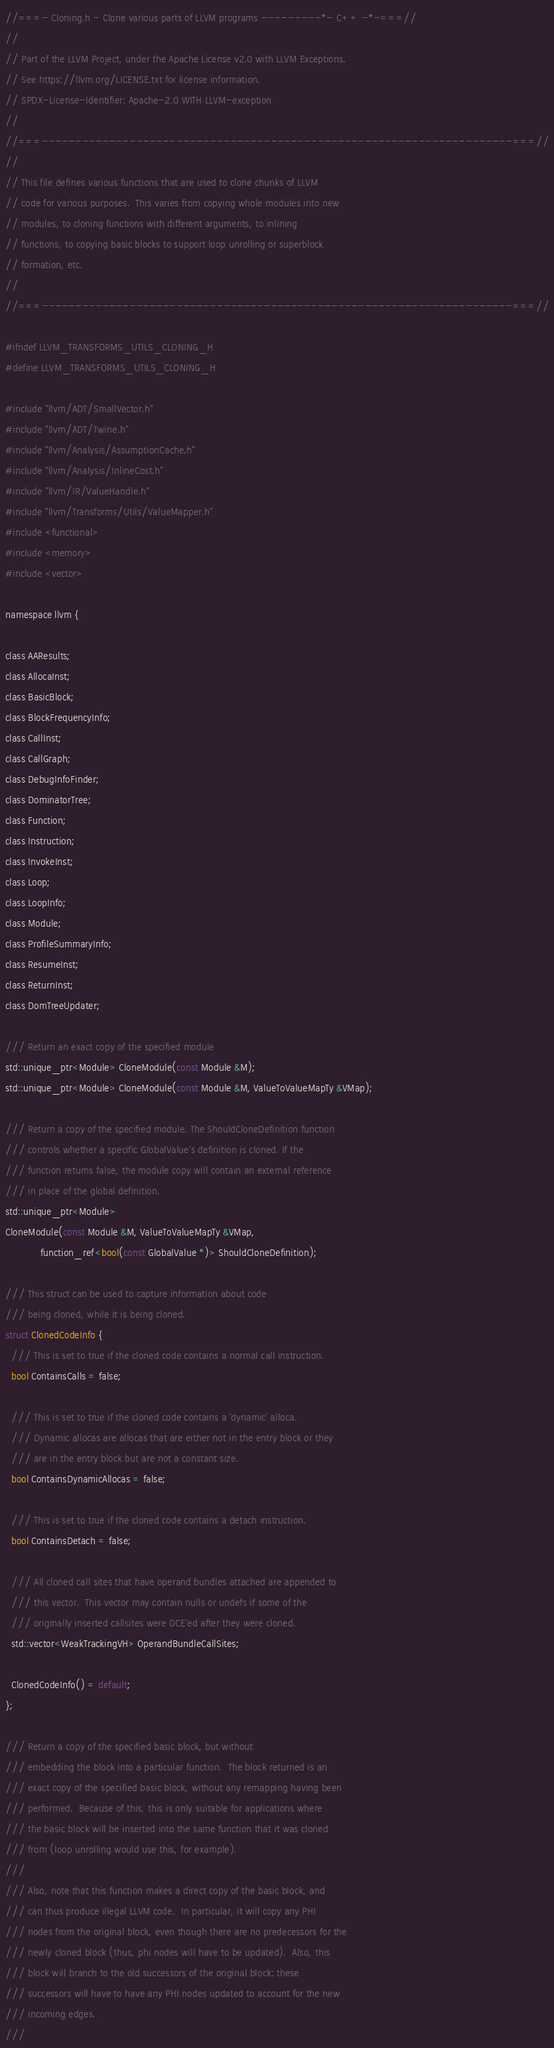Convert code to text. <code><loc_0><loc_0><loc_500><loc_500><_C_>//===- Cloning.h - Clone various parts of LLVM programs ---------*- C++ -*-===//
//
// Part of the LLVM Project, under the Apache License v2.0 with LLVM Exceptions.
// See https://llvm.org/LICENSE.txt for license information.
// SPDX-License-Identifier: Apache-2.0 WITH LLVM-exception
//
//===----------------------------------------------------------------------===//
//
// This file defines various functions that are used to clone chunks of LLVM
// code for various purposes.  This varies from copying whole modules into new
// modules, to cloning functions with different arguments, to inlining
// functions, to copying basic blocks to support loop unrolling or superblock
// formation, etc.
//
//===----------------------------------------------------------------------===//

#ifndef LLVM_TRANSFORMS_UTILS_CLONING_H
#define LLVM_TRANSFORMS_UTILS_CLONING_H

#include "llvm/ADT/SmallVector.h"
#include "llvm/ADT/Twine.h"
#include "llvm/Analysis/AssumptionCache.h"
#include "llvm/Analysis/InlineCost.h"
#include "llvm/IR/ValueHandle.h"
#include "llvm/Transforms/Utils/ValueMapper.h"
#include <functional>
#include <memory>
#include <vector>

namespace llvm {

class AAResults;
class AllocaInst;
class BasicBlock;
class BlockFrequencyInfo;
class CallInst;
class CallGraph;
class DebugInfoFinder;
class DominatorTree;
class Function;
class Instruction;
class InvokeInst;
class Loop;
class LoopInfo;
class Module;
class ProfileSummaryInfo;
class ResumeInst;
class ReturnInst;
class DomTreeUpdater;

/// Return an exact copy of the specified module
std::unique_ptr<Module> CloneModule(const Module &M);
std::unique_ptr<Module> CloneModule(const Module &M, ValueToValueMapTy &VMap);

/// Return a copy of the specified module. The ShouldCloneDefinition function
/// controls whether a specific GlobalValue's definition is cloned. If the
/// function returns false, the module copy will contain an external reference
/// in place of the global definition.
std::unique_ptr<Module>
CloneModule(const Module &M, ValueToValueMapTy &VMap,
            function_ref<bool(const GlobalValue *)> ShouldCloneDefinition);

/// This struct can be used to capture information about code
/// being cloned, while it is being cloned.
struct ClonedCodeInfo {
  /// This is set to true if the cloned code contains a normal call instruction.
  bool ContainsCalls = false;

  /// This is set to true if the cloned code contains a 'dynamic' alloca.
  /// Dynamic allocas are allocas that are either not in the entry block or they
  /// are in the entry block but are not a constant size.
  bool ContainsDynamicAllocas = false;

  /// This is set to true if the cloned code contains a detach instruction.
  bool ContainsDetach = false;

  /// All cloned call sites that have operand bundles attached are appended to
  /// this vector.  This vector may contain nulls or undefs if some of the
  /// originally inserted callsites were DCE'ed after they were cloned.
  std::vector<WeakTrackingVH> OperandBundleCallSites;

  ClonedCodeInfo() = default;
};

/// Return a copy of the specified basic block, but without
/// embedding the block into a particular function.  The block returned is an
/// exact copy of the specified basic block, without any remapping having been
/// performed.  Because of this, this is only suitable for applications where
/// the basic block will be inserted into the same function that it was cloned
/// from (loop unrolling would use this, for example).
///
/// Also, note that this function makes a direct copy of the basic block, and
/// can thus produce illegal LLVM code.  In particular, it will copy any PHI
/// nodes from the original block, even though there are no predecessors for the
/// newly cloned block (thus, phi nodes will have to be updated).  Also, this
/// block will branch to the old successors of the original block: these
/// successors will have to have any PHI nodes updated to account for the new
/// incoming edges.
///</code> 